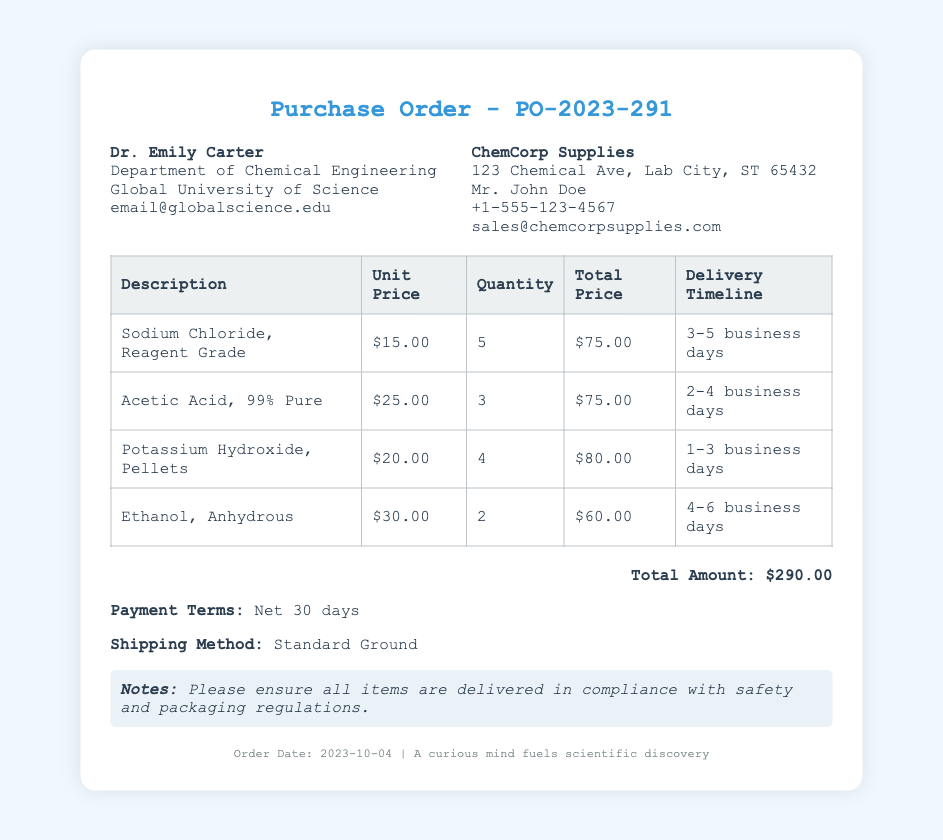what is the purchase order number? The purchase order number is specified in the title of the document as PO-2023-291.
Answer: PO-2023-291 who is the scientist placing the order? The scientist's name is provided in the document under the 'scientist info' section as Dr. Emily Carter.
Answer: Dr. Emily Carter how many units of Potassium Hydroxide are being ordered? The quantity of Potassium Hydroxide is listed in the table under the 'Quantity' column for that item as 4.
Answer: 4 what is the total amount for this purchase order? The total amount is listed at the bottom of the purchase order as $290.00.
Answer: $290.00 which item has the longest delivery timeline? The item with the longest delivery timeline is Ethanol, Anhydrous, which states a timeline of 4-6 business days.
Answer: Ethanol, Anhydrous what is the unit price of Acetic Acid? The unit price of Acetic Acid is found in the table under the 'Unit Price' column, indicating $25.00.
Answer: $25.00 who is the supplier for the chemical supplies? The supplier's name is provided in the 'supplier info' section as ChemCorp Supplies.
Answer: ChemCorp Supplies what are the payment terms for this order? The payment terms are specified in the document as Net 30 days.
Answer: Net 30 days what is the shipping method mentioned in the document? The shipping method is indicated in the document as Standard Ground.
Answer: Standard Ground 